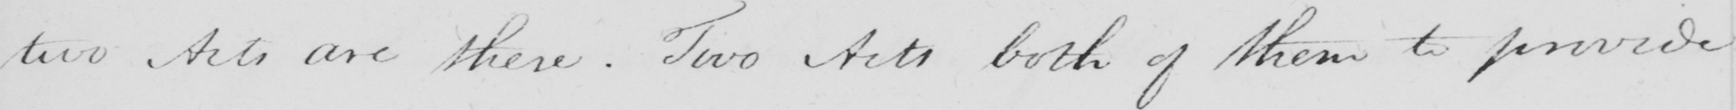Can you read and transcribe this handwriting? two acts are there . Two Acts both of them to provide 